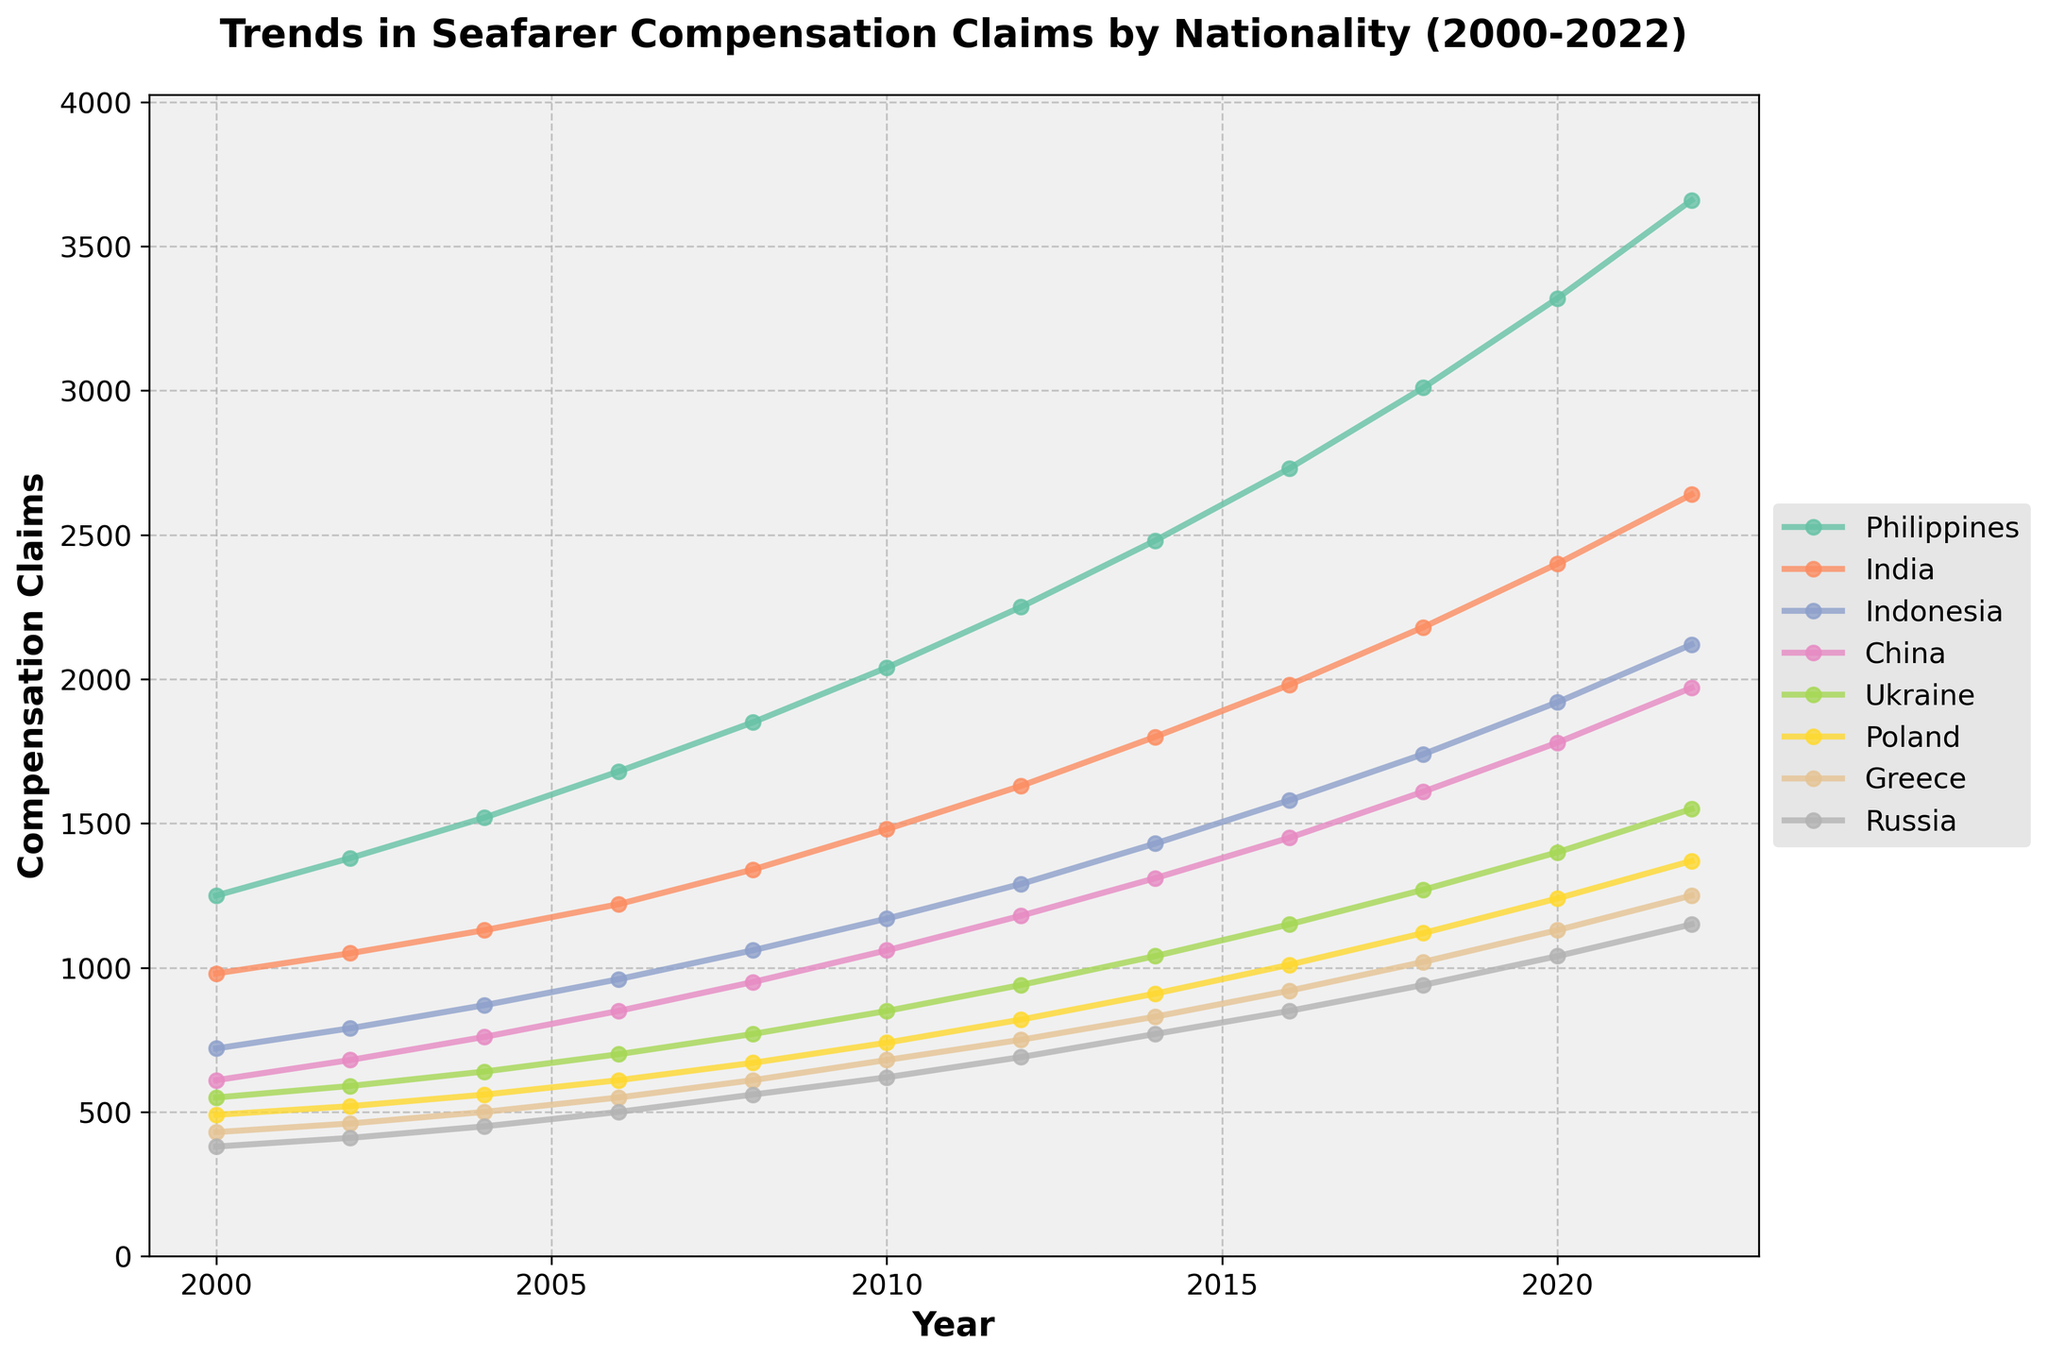What's the trend in compensation claims for Filipino seafarers from 2000 to 2022? To see the trend, observe the line for the Philippines from 2000 to 2022. The line consistently moves upward, indicating a continuous increase in compensation claims over the period.
Answer: Increasing Which nationality had the lowest number of compensation claims in the year 2000? Look at the values for each nationality in the year 2000. The lowest value is for Russia, which is 380.
Answer: Russia By how much did the compensation claims for Indian seafarers increase from 2010 to 2022? Check the values for India in 2010 and 2022: 1480 and 2640, respectively. Calculate the difference: 2640 - 1480 = 1160.
Answer: 1160 Which two nationalities have the most similar number of compensation claims in 2022? Compare the values for each nationality in 2022. China has 1970 and Indonesia has 2120, which are the closest in value.
Answer: China and Indonesia What is the average number of compensation claims for Ukrainian seafarers over the entire period? Add up the values for Ukraine from all the years and divide by the number of years (12): (550 + 590 + 640 + 700 + 770 + 850 + 940 + 1040 + 1150 + 1270 + 1400 + 1550) / 12 = 9650 / 12 ≈ 804.17.
Answer: 804.17 Which nationality showed the largest increase in compensation claims from 2000 to 2022? Calculate the increase for each nationality from 2000 to 2022 and compare them. Philippines increased by 3660 - 1250 = 2410, which is the largest.
Answer: Philippines Between 2010 and 2016, which nationality had the highest growth rate in compensation claims? Calculate the percentage increase for each nationality from 2010 to 2016 and compare them. For example, for the Philippines, (2730 - 2040) / 2040 * 100 ≈ 33.8%. Repeat for other nationalities—Indonesia has the highest rate: (1580 - 1170) / 1170 * 100 ≈ 35.0%.
Answer: Indonesia How does the trend for Greek seafarers' compensation claims from 2000 to 2022 compare to Ukrainian seafarers? Observe the trends for Greece and Ukraine. Both lines show a consistent upward trend, but Ukraine's claims are higher at each point except the beginning.
Answer: Similar upward trend but Ukrainian claims are generally higher What is the total number of compensation claims for Polish seafarers from 2000 to 2022? Sum the values for Poland across all years: 490 + 520 + 560 + 610 + 670 + 740 + 820 + 910 + 1010 + 1120 + 1240 + 1370 = 10960.
Answer: 10960 Which year marked a significant spike in compensation claims for Chinese seafarers? Observe the values for China year by year for any significant jumps. From 2008 (950) to 2010 (1060), there is a noticeable increase. Thus, 2010 marks a significant spike.
Answer: 2010 